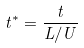Convert formula to latex. <formula><loc_0><loc_0><loc_500><loc_500>t ^ { * } = \frac { t } { L / U }</formula> 